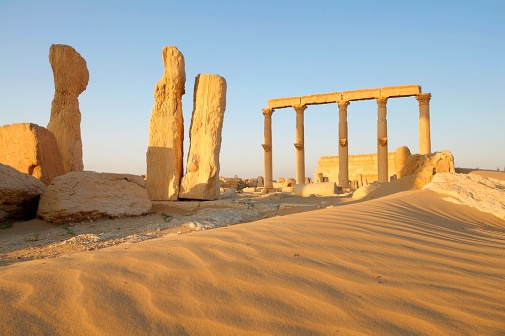Explain the visual content of the image in great detail. The image captures an ancient temple situated in the heart of a desert. To the right, six columns of a light-colored stone, weathered by time, still stand upright. These columns appear to be remnants of a once grand structure. Scattered around these, various other stones, likely fallen fragments of the temple, can also be seen. The foreground is dominated by a sweeping expanse of golden sand dunes, indicative of an arid environment. The clear, light blue sky above suggests a bright, sunny day. The relative positions of the ruins hint at the former magnificence of this now dilapidated structure, vividly conveying the passage of time and the impact of natural elements on human creations. 